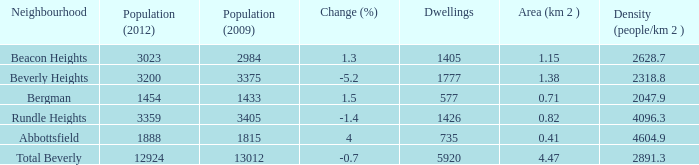How many Dwellings does Beverly Heights have that have a change percent larger than -5.2? None. 